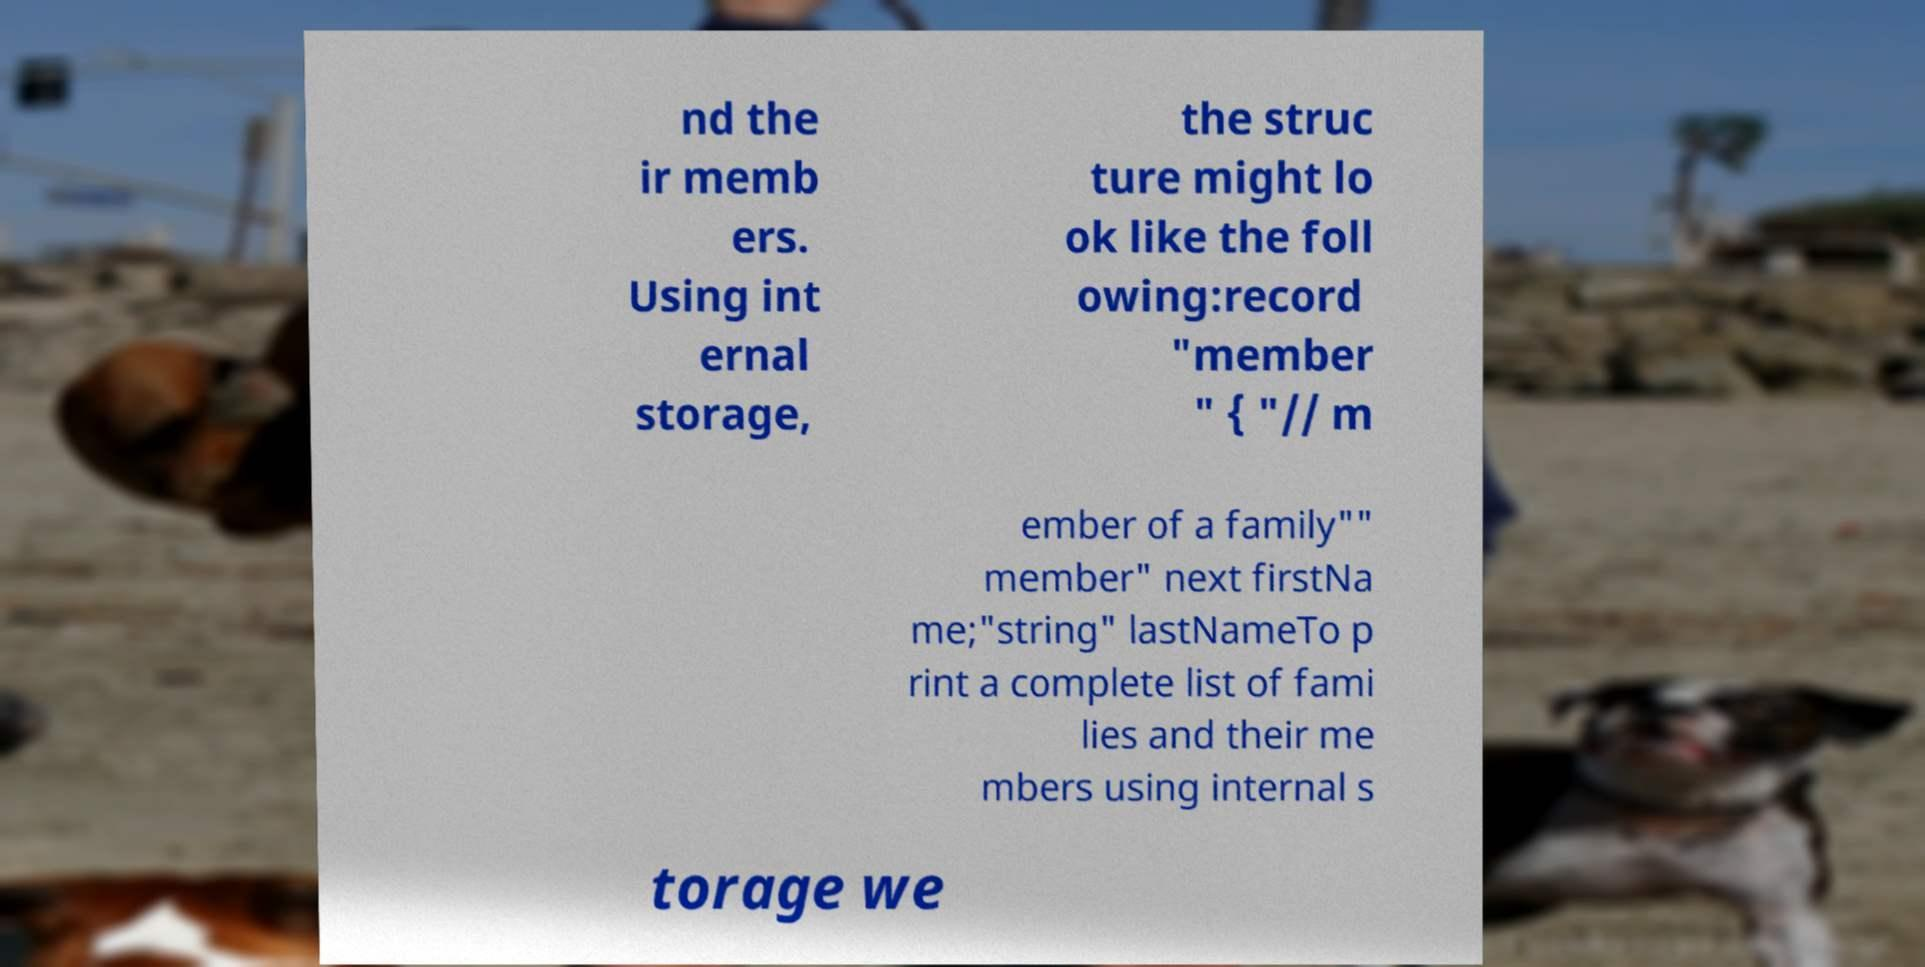For documentation purposes, I need the text within this image transcribed. Could you provide that? nd the ir memb ers. Using int ernal storage, the struc ture might lo ok like the foll owing:record "member " { "// m ember of a family"" member" next firstNa me;"string" lastNameTo p rint a complete list of fami lies and their me mbers using internal s torage we 